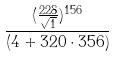Convert formula to latex. <formula><loc_0><loc_0><loc_500><loc_500>\frac { ( \frac { 2 2 8 } { \sqrt { 1 } } ) ^ { 1 5 6 } } { ( 4 + 3 2 0 \cdot 3 5 6 ) }</formula> 